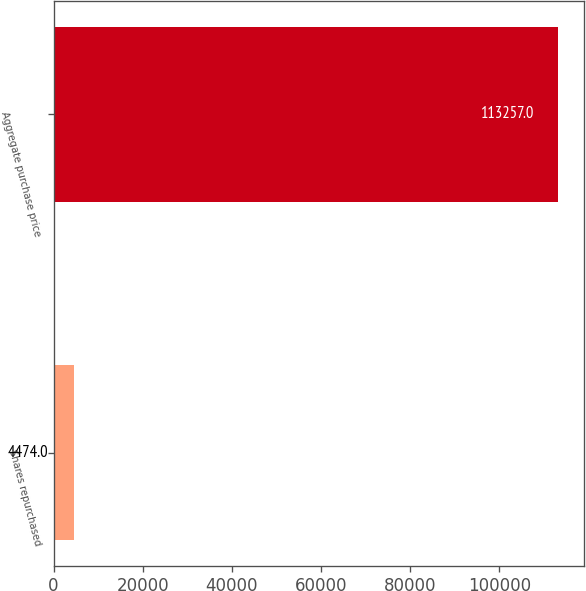Convert chart. <chart><loc_0><loc_0><loc_500><loc_500><bar_chart><fcel>Shares repurchased<fcel>Aggregate purchase price<nl><fcel>4474<fcel>113257<nl></chart> 